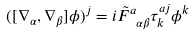<formula> <loc_0><loc_0><loc_500><loc_500>( [ \nabla _ { \alpha } , \nabla _ { \beta } ] \phi ) ^ { j } = i \tilde { F } ^ { a } _ { \ \alpha \beta } \tau ^ { a j } _ { k } \phi ^ { k }</formula> 